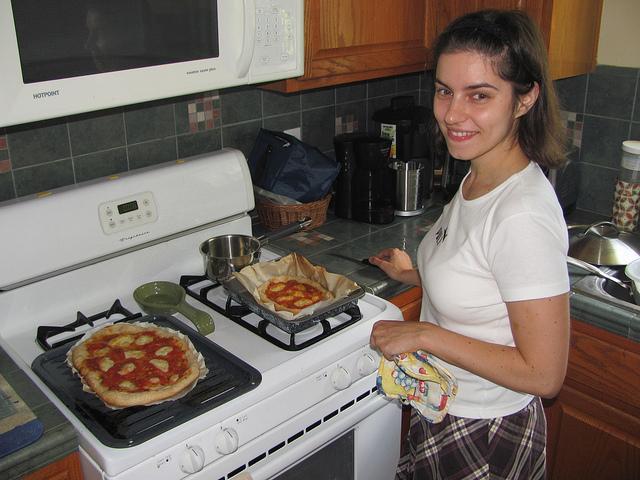How many dogs are shown?
Give a very brief answer. 0. 